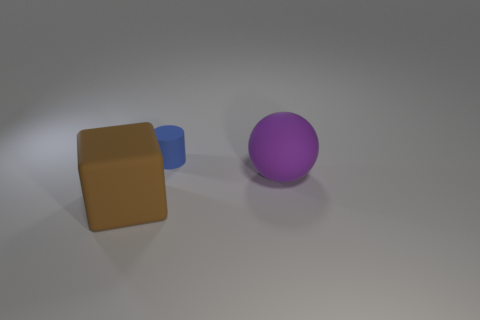What is the lighting like in the scene? The lighting in the scene appears soft and diffused, providing a gentle illumination to the objects from the upper right side, which creates subtle shadows on the left side of the objects. 